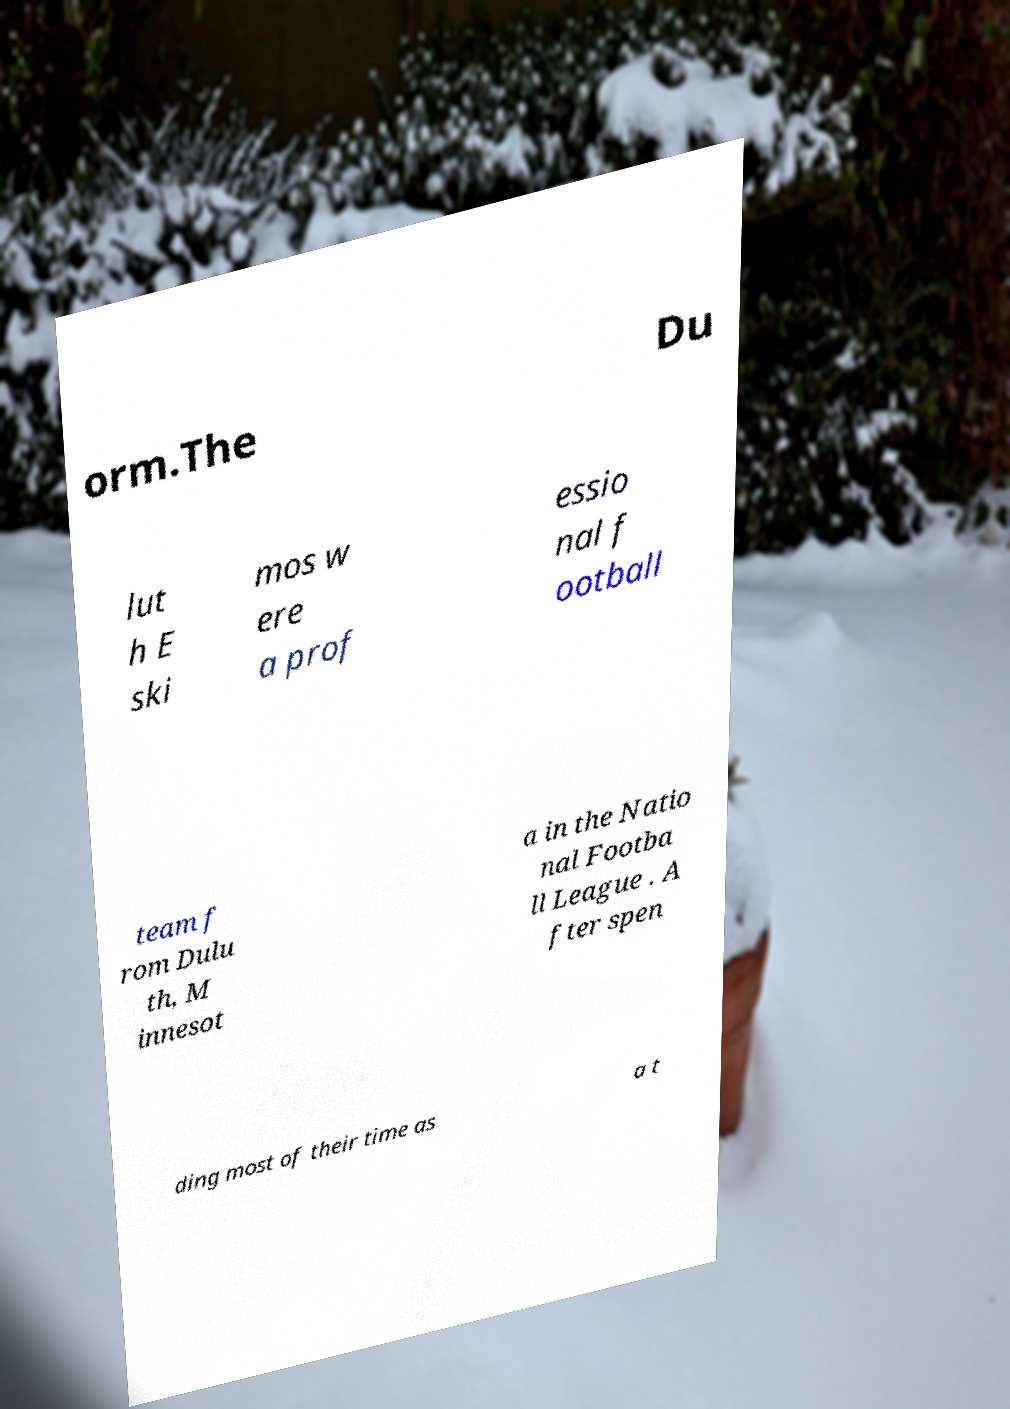Can you read and provide the text displayed in the image?This photo seems to have some interesting text. Can you extract and type it out for me? orm.The Du lut h E ski mos w ere a prof essio nal f ootball team f rom Dulu th, M innesot a in the Natio nal Footba ll League . A fter spen ding most of their time as a t 